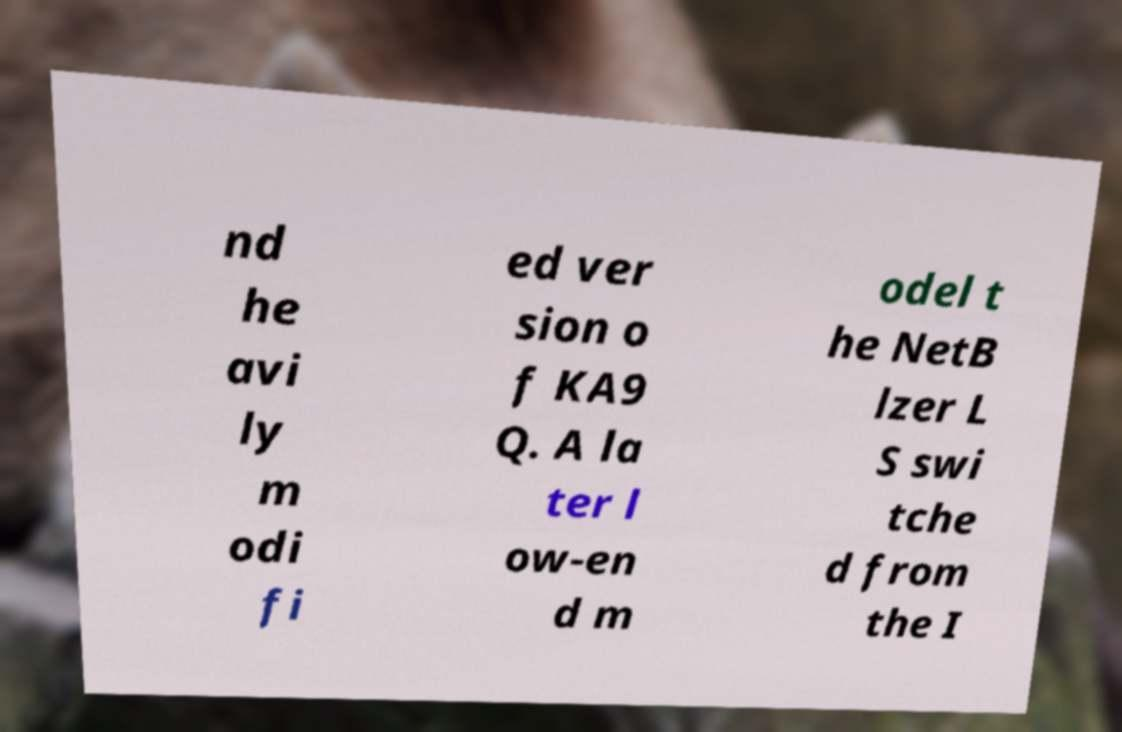I need the written content from this picture converted into text. Can you do that? nd he avi ly m odi fi ed ver sion o f KA9 Q. A la ter l ow-en d m odel t he NetB lzer L S swi tche d from the I 